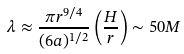Convert formula to latex. <formula><loc_0><loc_0><loc_500><loc_500>\lambda \approx \frac { \pi r ^ { 9 / 4 } } { ( 6 a ) ^ { 1 / 2 } } \left ( \frac { H } { r } \right ) \sim 5 0 M</formula> 